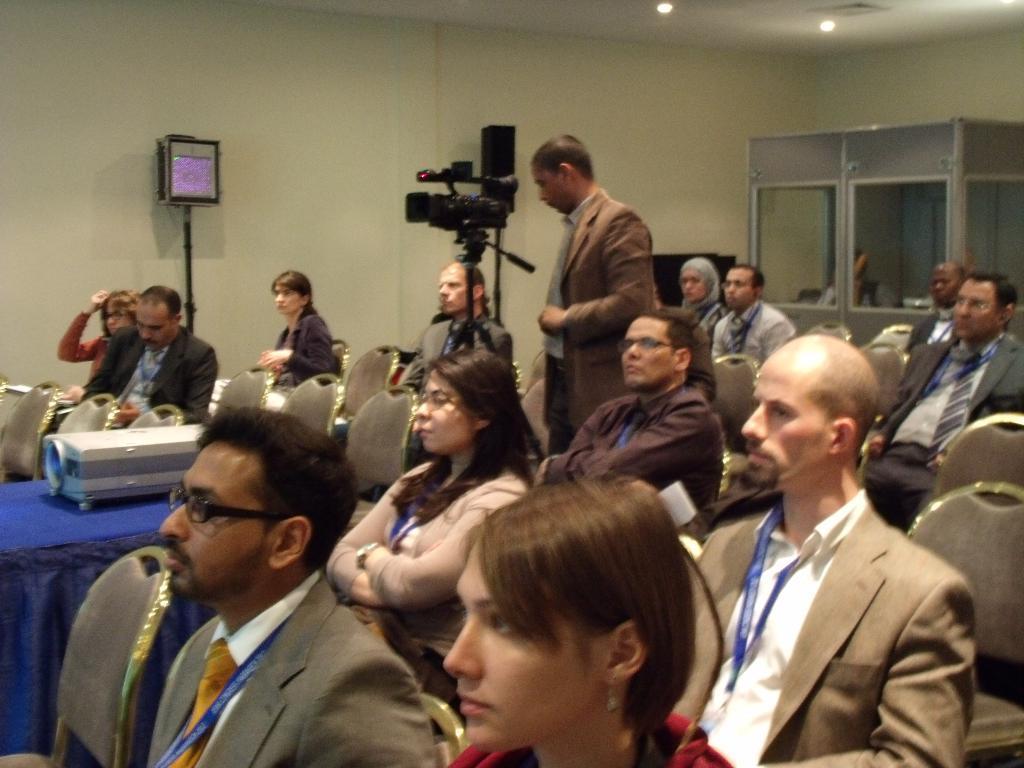Please provide a concise description of this image. In this image there are people sitting on the chairs. There is a projector on the table. There is a person standing in front of the camera. In the background of the image there is a wall. In front of the wall there is some object. There is a person standing inside the cabin and there are some objects. At the top of the image there are lights. 